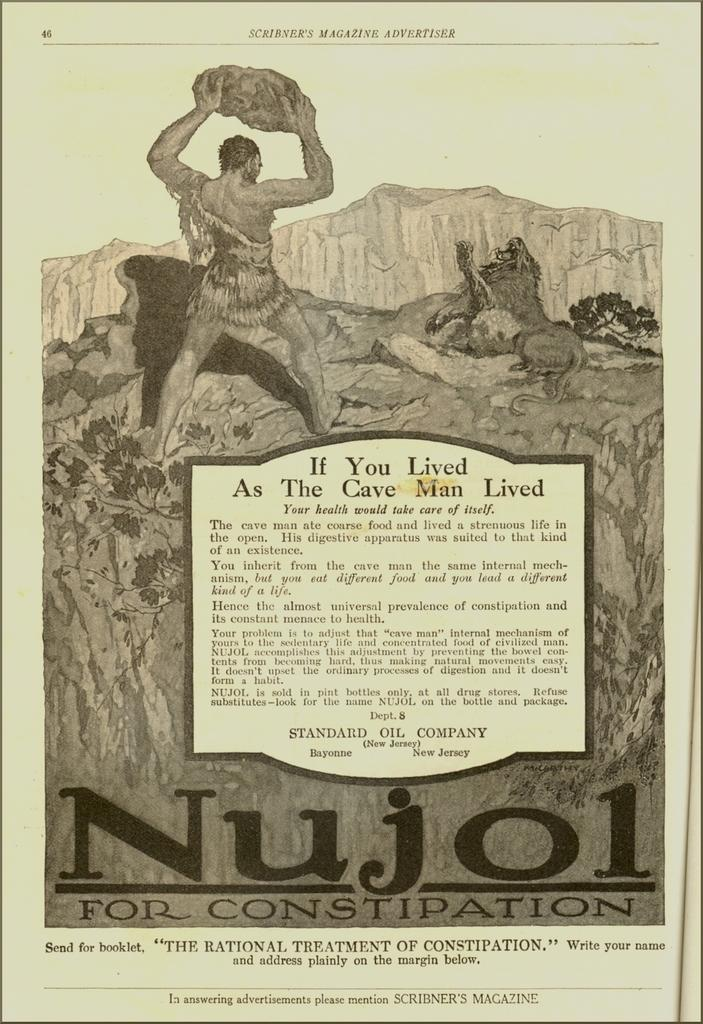What is featured on the poster in the image? There is a poster in the image that has both writing and pictures. Can you describe the pictures on the poster? The poster features a picture of a person and a picture of an animal. What is the purpose of the writing on the poster? The writing on the poster provides additional information or context about the images. What type of chalk is being used to draw the animal on the poster? There is no chalk present in the image, and the animal is already drawn on the poster. 